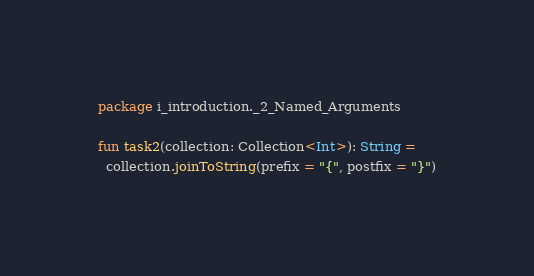Convert code to text. <code><loc_0><loc_0><loc_500><loc_500><_Kotlin_>package i_introduction._2_Named_Arguments

fun task2(collection: Collection<Int>): String =
  collection.joinToString(prefix = "{", postfix = "}")
</code> 